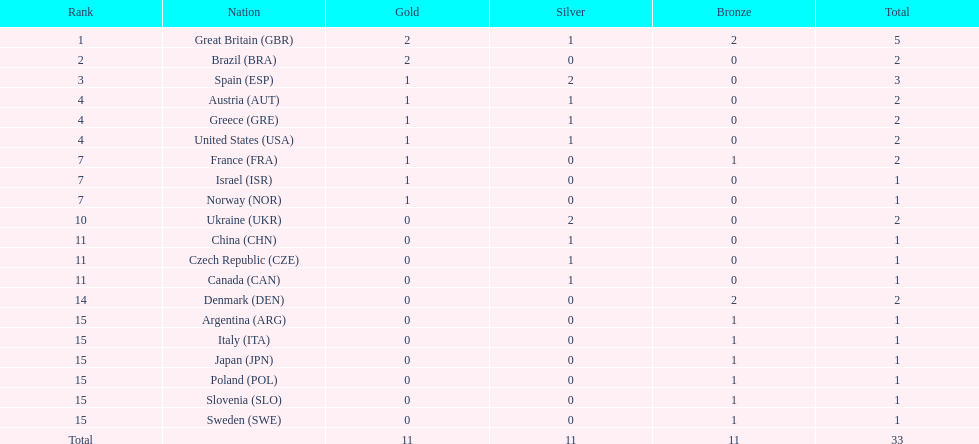What was the count of silver medals obtained by ukraine? 2. 